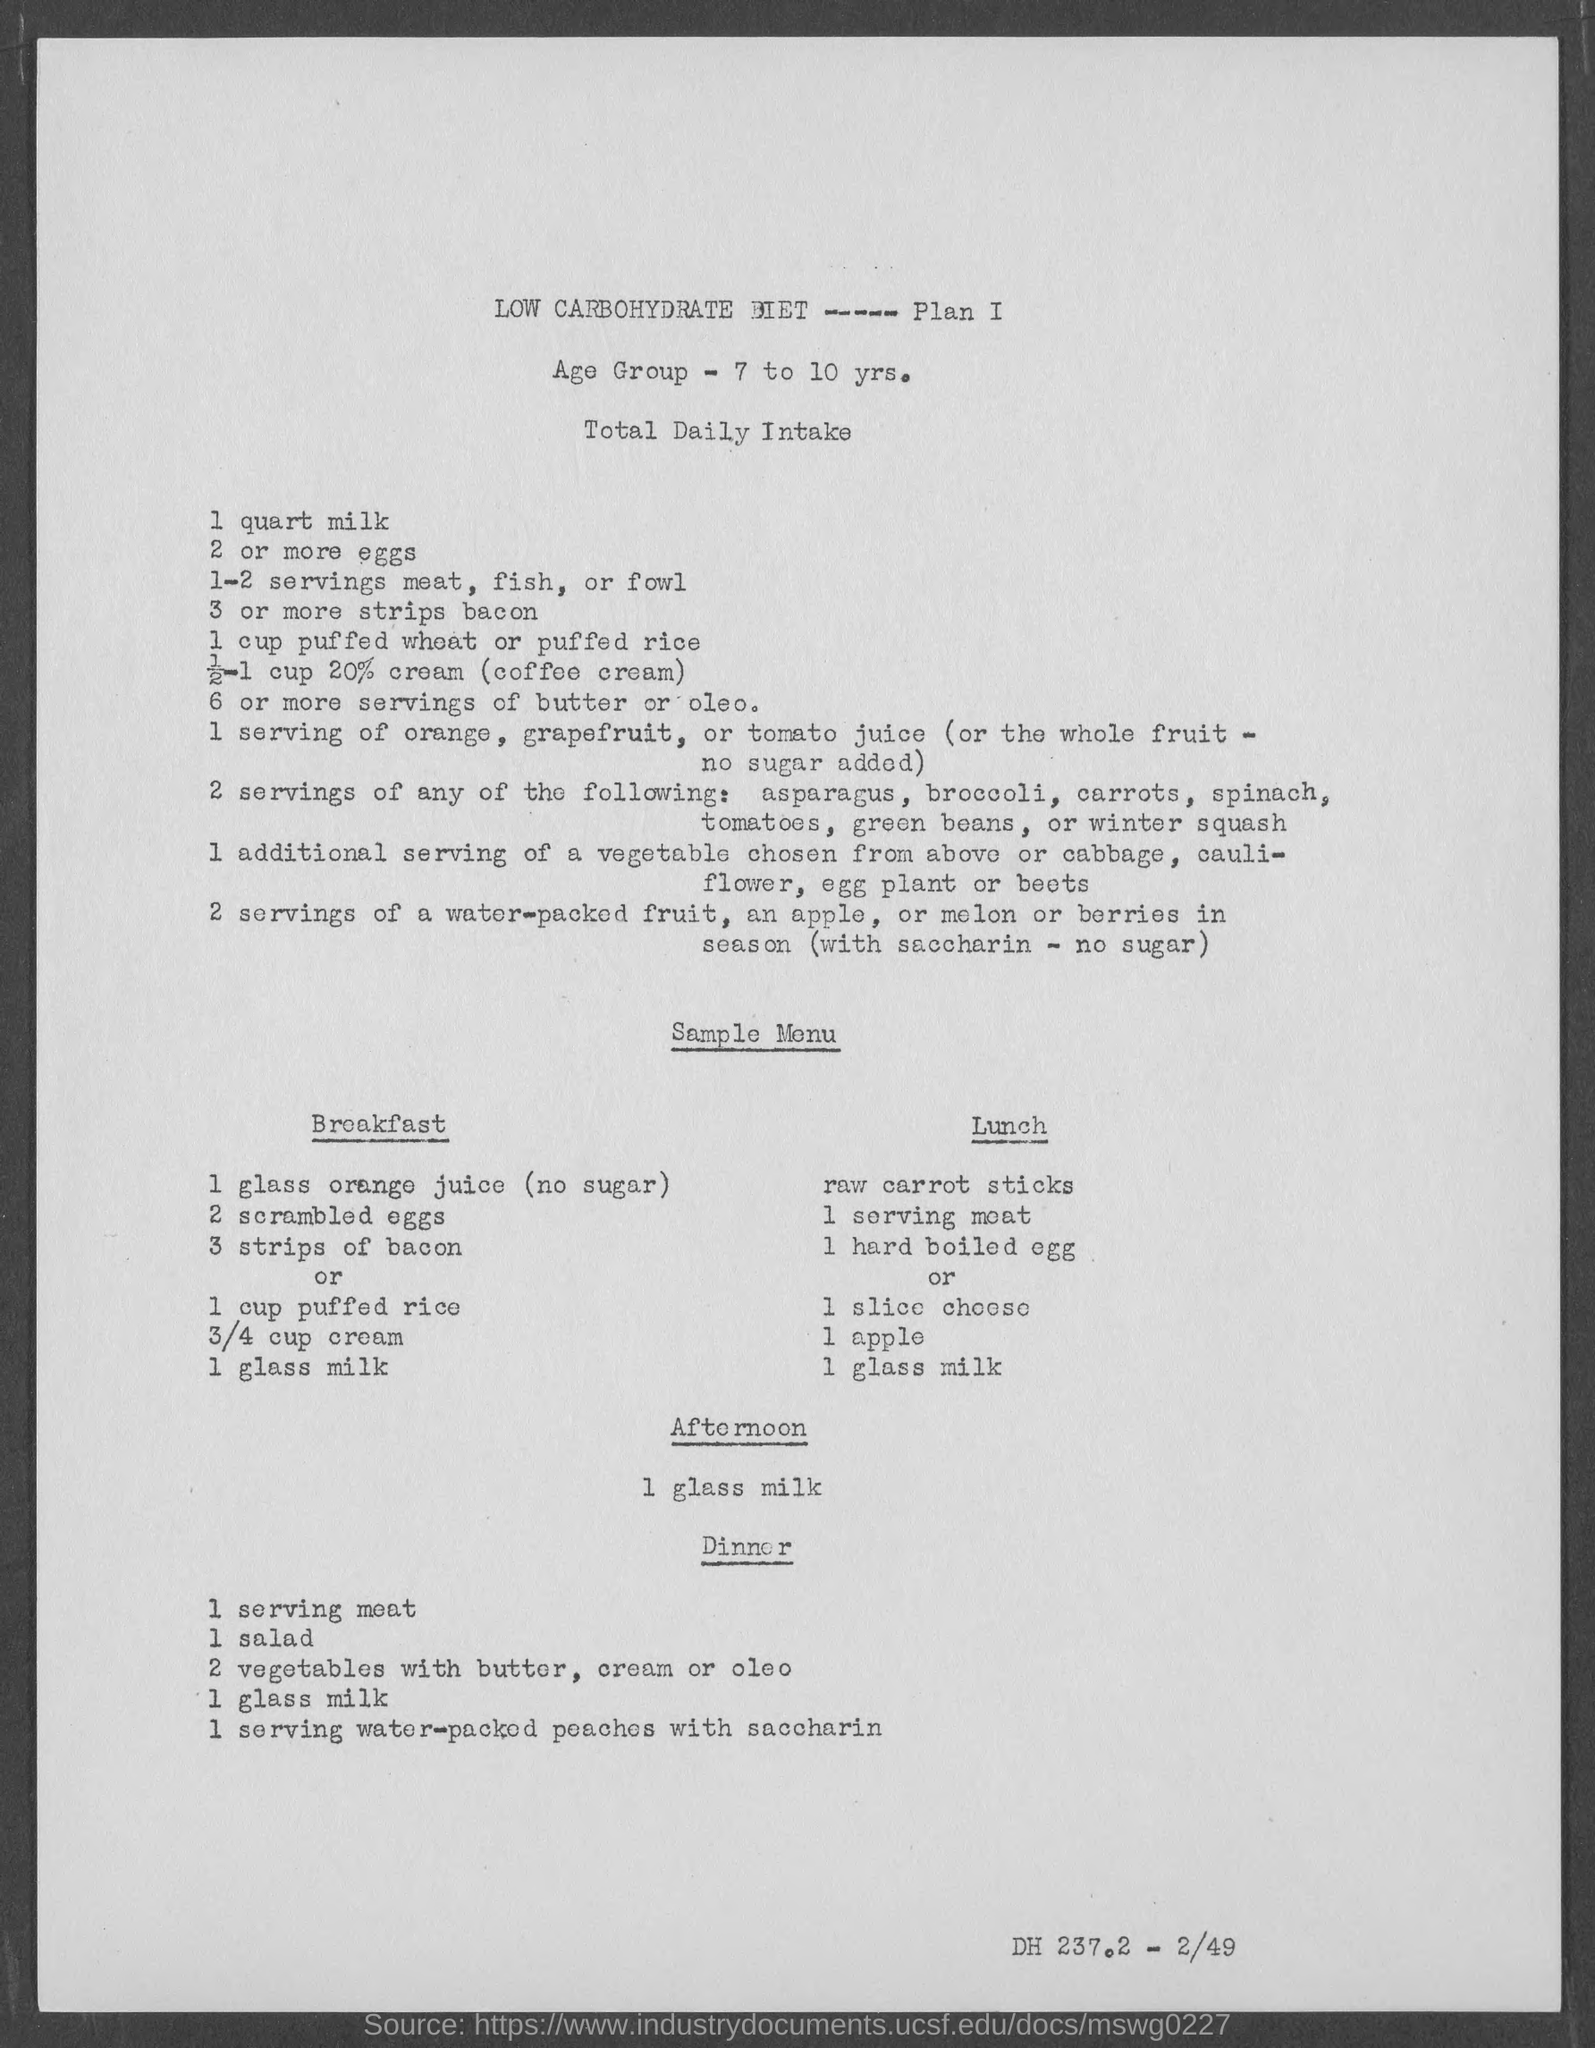Identify some key points in this picture. The daily intake of milk is 1 quart. We offer a sample menu for the afternoon that includes one glass of milk. The age group for this activity is 7 to 10 years old. 